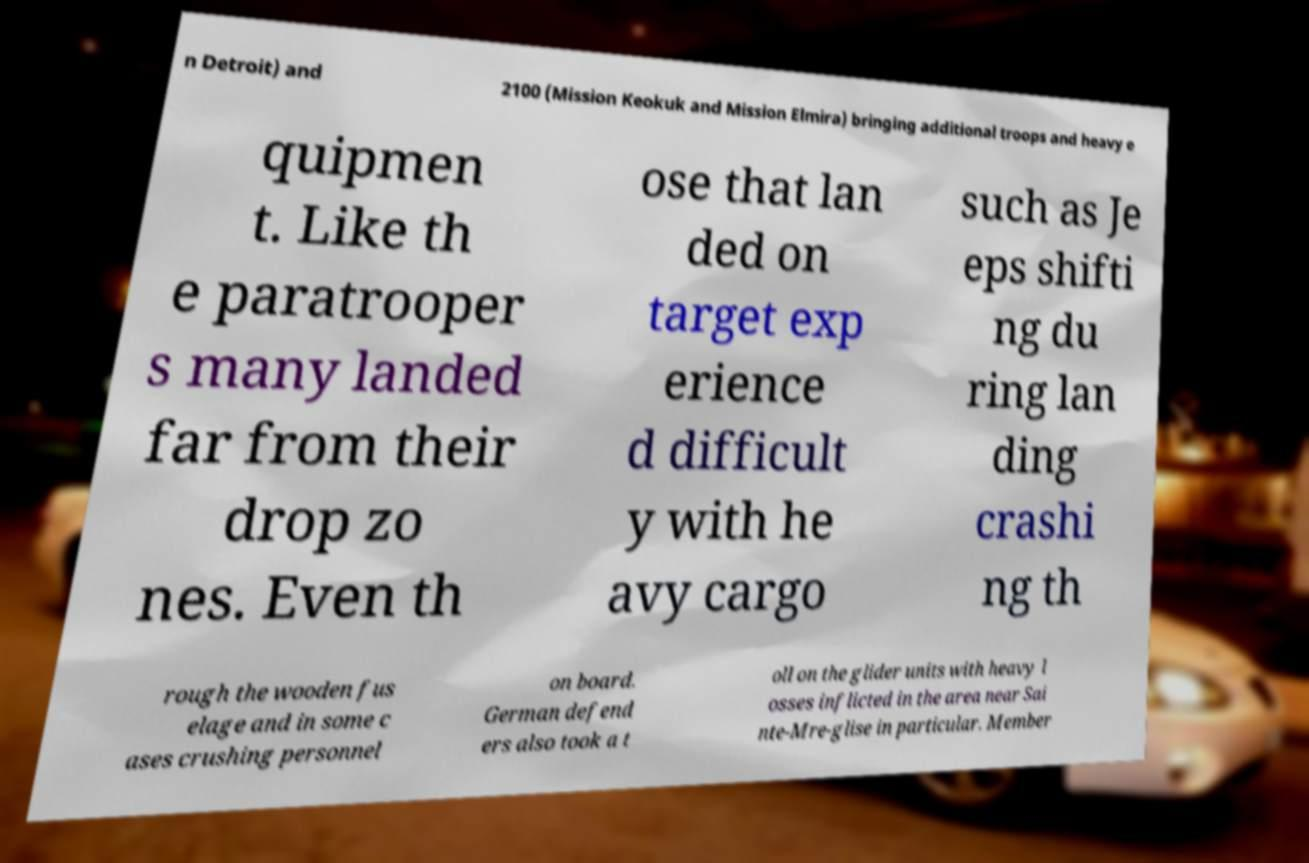For documentation purposes, I need the text within this image transcribed. Could you provide that? n Detroit) and 2100 (Mission Keokuk and Mission Elmira) bringing additional troops and heavy e quipmen t. Like th e paratrooper s many landed far from their drop zo nes. Even th ose that lan ded on target exp erience d difficult y with he avy cargo such as Je eps shifti ng du ring lan ding crashi ng th rough the wooden fus elage and in some c ases crushing personnel on board. German defend ers also took a t oll on the glider units with heavy l osses inflicted in the area near Sai nte-Mre-glise in particular. Member 